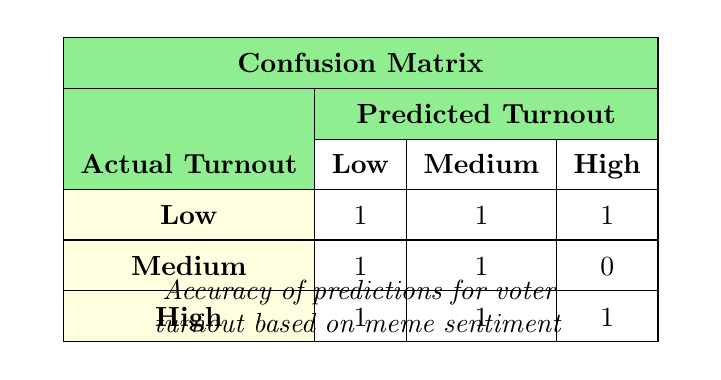What is the predicted turnout for actual Low turnout? From the table, we can see that for the "Low" actual turnout, the predicted values are 1 (Low), 1 (Medium), and 1 (High). These represent the counts of how often the predictions matched or didn't match the actual turnout.
Answer: 1 Low, 1 Medium, 1 High How many times were Medium turnouts predicted for actual High turnout? Looking at the row for actual High turnout, we see that the predicted Medium turnout has a count of 1. This means there was 1 instance where a Medium turnout was predicted when the actual turnout was High.
Answer: 1 What is the total count of predictions made for actual Medium turnout? For the Medium actual turnout, we have predictions of 1 (Low), 1 (Medium), and 0 (High). Adding these three values together gives us a total of 2 predictions made for actual Medium turnout.
Answer: 2 Do any predictions for actual Low turnout show a High predicted turnout? In the row for actual Low turnout, the predicted turnout shows counts of 1 (Low), 1 (Medium), and 1 (High). Since there is a count greater than 0 for High, it indicates that there was at least one prediction for High when the actual was Low.
Answer: Yes What is the average number of predictions across all actual turnout categories? To calculate the average, we first sum all values in the table: (1 + 1 + 1) for Low, (1 + 1 + 0) for Medium, and (1 + 1 + 1) for High, giving us a total of 8 predictions. There are 3 different actual turnout categories, so we divide 8 by 3, resulting in an average of approximately 2.67 predictions per category.
Answer: 2.67 How many instances were there when the predicted turnout was Low? By inspecting the table, we can find counts for each actual turnout category with corresponding Low predictions: 1 (for Low), 1 (for Medium), and 1 (for High). Adding these counts gives us a total of 3 instances where the predicted turnout was Low.
Answer: 3 Which actual turnout category has the highest number of total predictions? To determine this, we can sum the column values: Low has 3, Medium has 2, and High has 3. Both Low and High have the same highest count of 3, so they are tied for the highest number of predictions made.
Answer: Low and High Is there a case where a Medium actual turnout had a Low predicted turnout? By examining the table data, the Medium actual turnout does have a count of 1 for Low predicted turnout. Therefore, there is indeed a case where the predicted turnout was Low while the actual was Medium.
Answer: Yes 